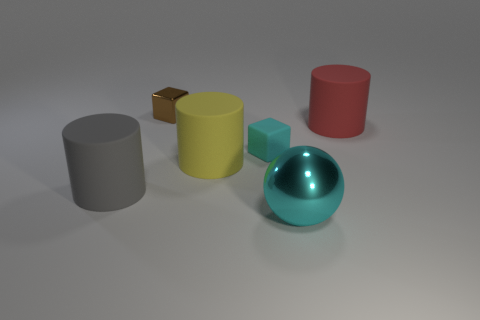Subtract all yellow cylinders. How many cylinders are left? 2 Subtract all large cyan rubber blocks. Subtract all big metal spheres. How many objects are left? 5 Add 6 cylinders. How many cylinders are left? 9 Add 2 cyan metallic objects. How many cyan metallic objects exist? 3 Add 3 large cyan balls. How many objects exist? 9 Subtract 0 brown balls. How many objects are left? 6 Subtract all blocks. How many objects are left? 4 Subtract 2 cubes. How many cubes are left? 0 Subtract all purple balls. Subtract all purple blocks. How many balls are left? 1 Subtract all purple blocks. How many yellow balls are left? 0 